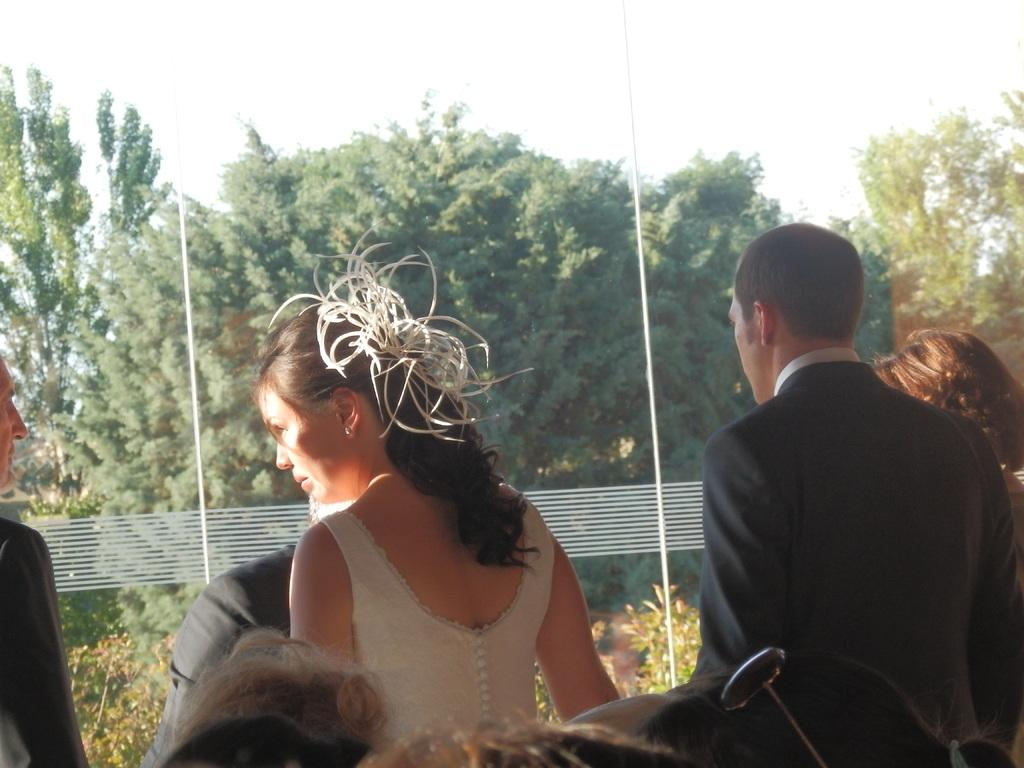What are the people in the image wearing? The people in the image are wearing clothes. What is a feature of the building in the image? There is a glass window in the image. What can be seen outside the window? Trees, plants, and the sky are visible outside the window. What type of fork can be seen on the edge of the representative's desk in the image? There is no fork or representative's desk present in the image. 